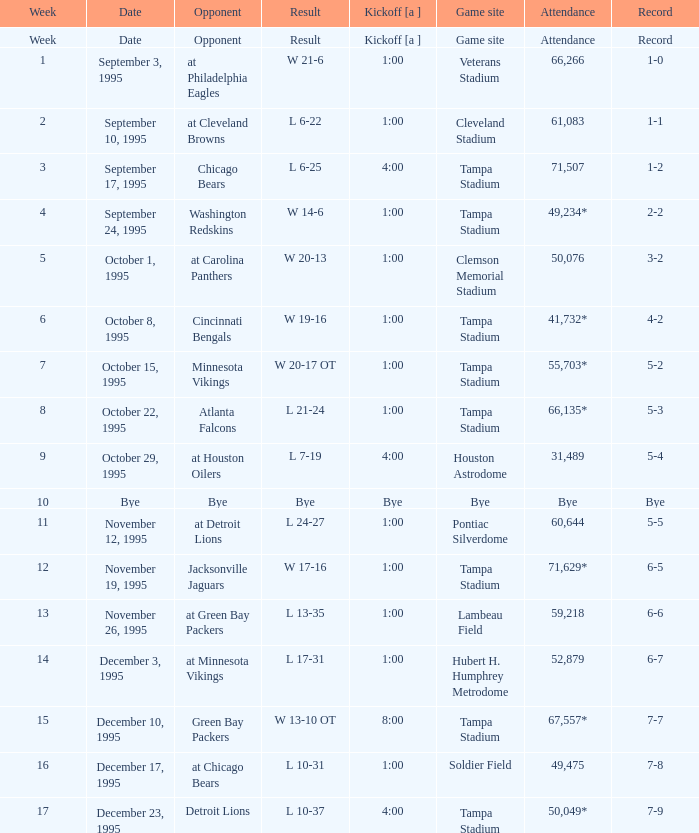What week was it on November 19, 1995? 12.0. 